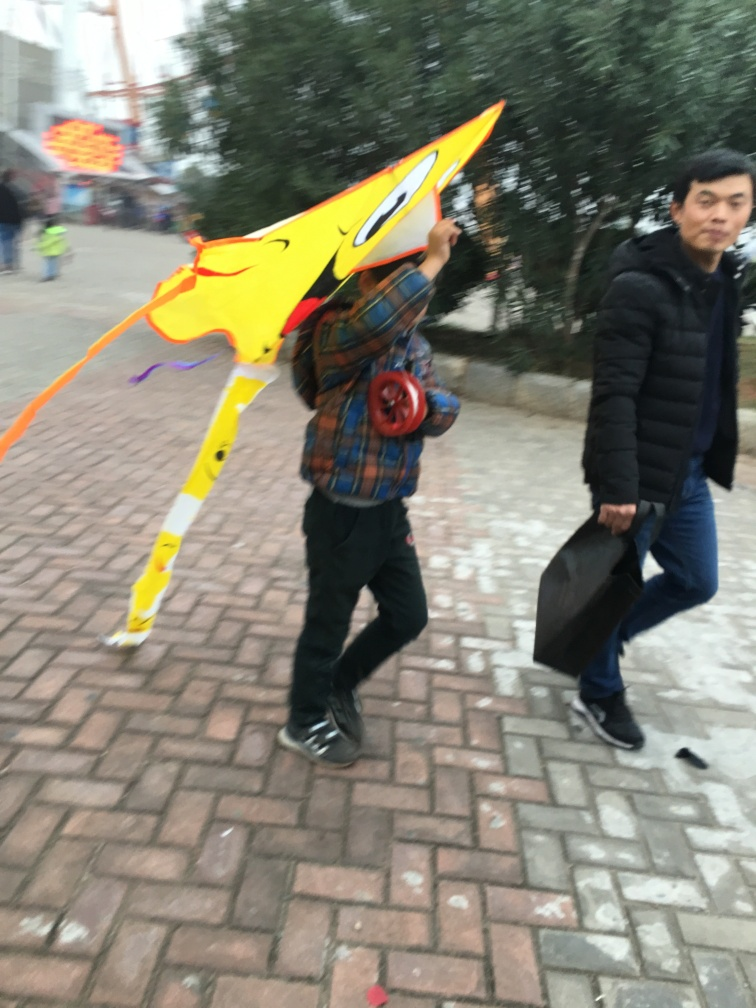Can you describe the atmosphere or context surrounding the individual in the image? The person is walking through what appears to be an urban environment, possibly a street or public square. The blurred scenery and other person in the background suggest a bustling atmosphere, where the individual with the kite is perhaps heading to a more tranquil location for leisure activities. 